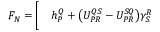<formula> <loc_0><loc_0><loc_500><loc_500>\begin{array} { r l } { F _ { N } = \Big [ } & h _ { P } ^ { Q } + \Big ( U _ { P R } ^ { Q S } - U _ { P R } ^ { S Q } \Big ) \gamma _ { S } ^ { R } } \end{array}</formula> 